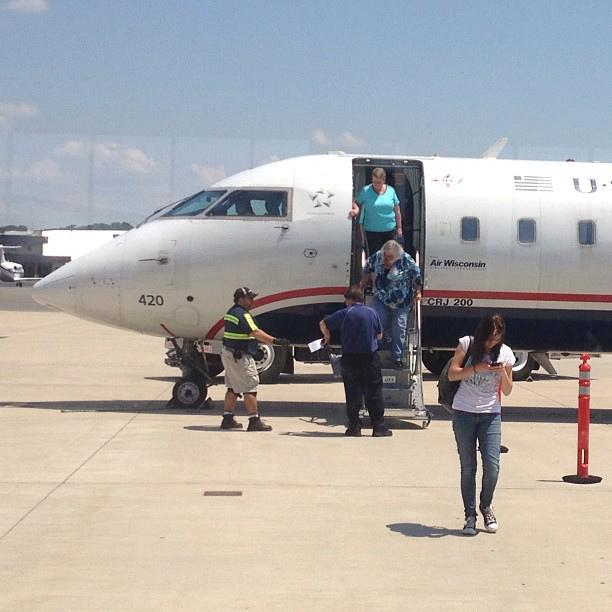What is the woman in the white shirt using in her hands?

Choices:
A) calculator
B) makeup
C) gameboy
D) phone phone 